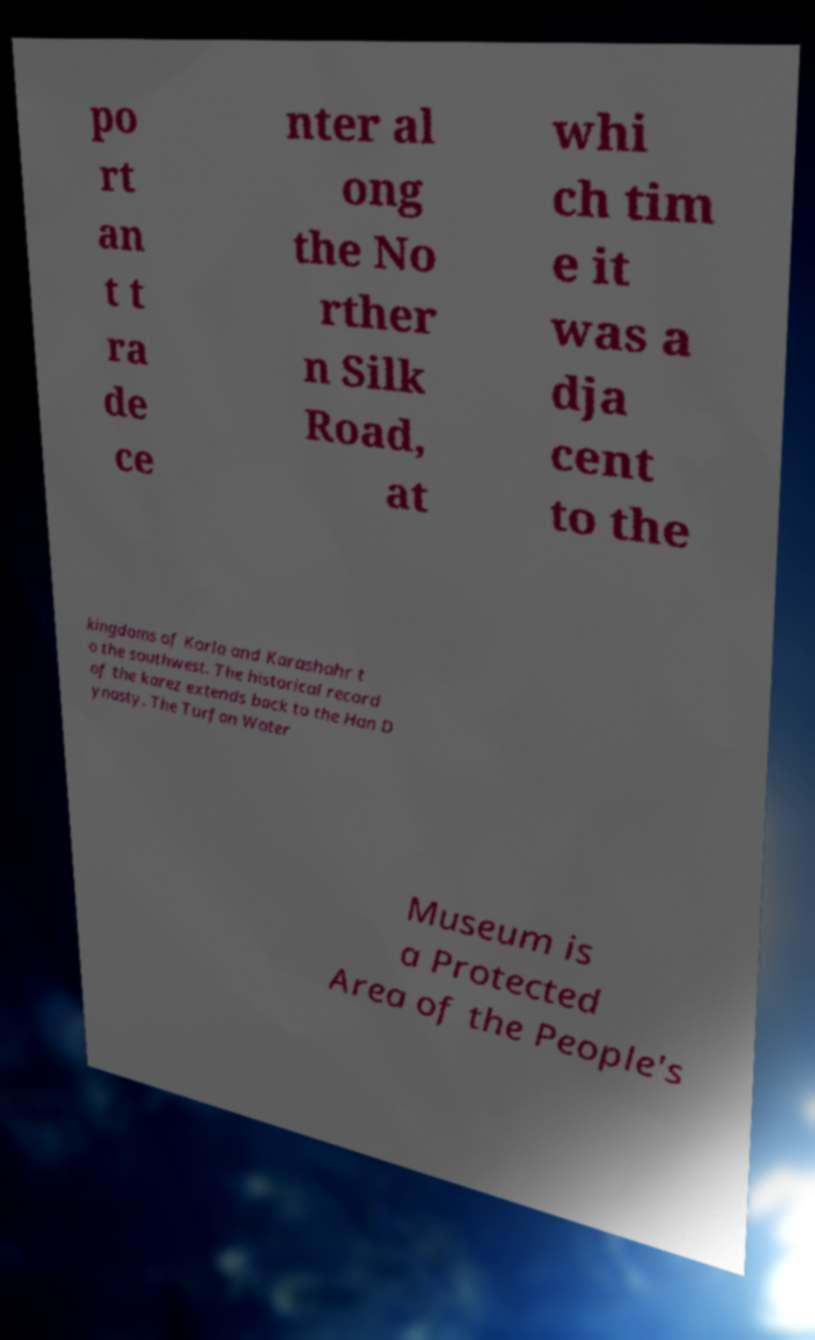What messages or text are displayed in this image? I need them in a readable, typed format. po rt an t t ra de ce nter al ong the No rther n Silk Road, at whi ch tim e it was a dja cent to the kingdoms of Korla and Karashahr t o the southwest. The historical record of the karez extends back to the Han D ynasty. The Turfan Water Museum is a Protected Area of the People's 